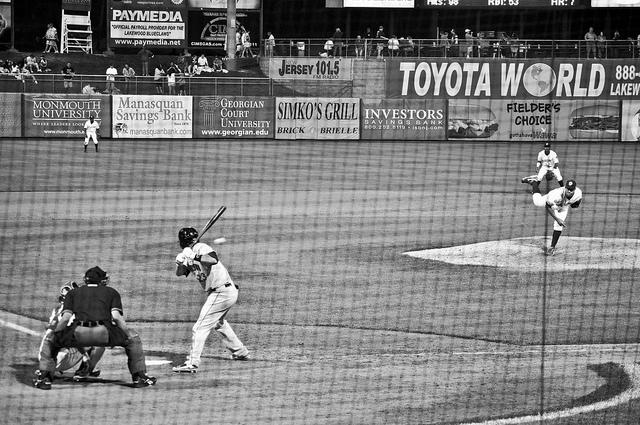What state is this field most likely in? Please explain your reasoning. new jersey. There is a sign for manasquan bank. this bank is located in that state. 